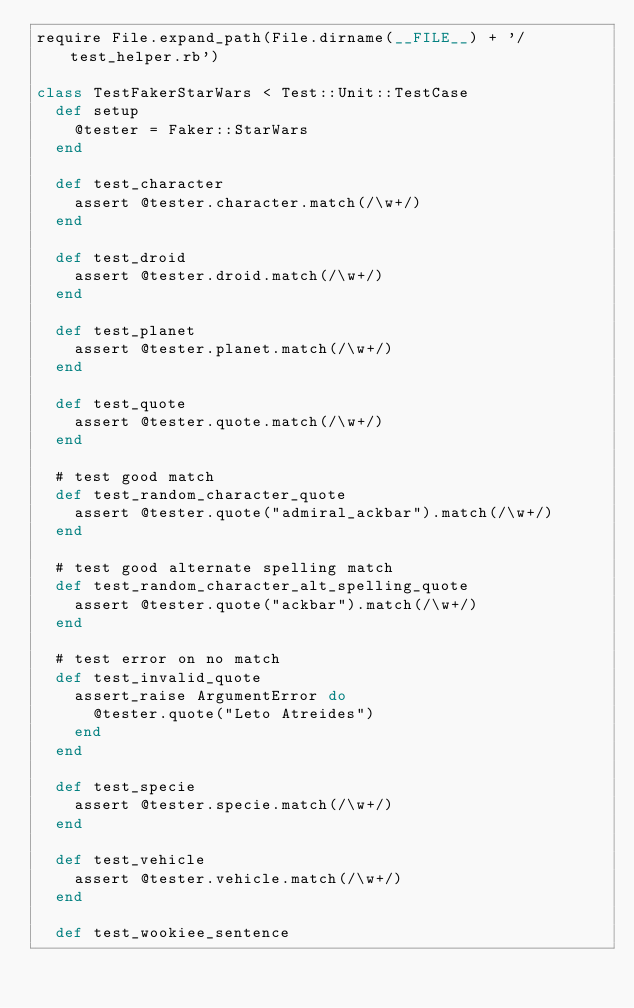Convert code to text. <code><loc_0><loc_0><loc_500><loc_500><_Ruby_>require File.expand_path(File.dirname(__FILE__) + '/test_helper.rb')

class TestFakerStarWars < Test::Unit::TestCase
  def setup
    @tester = Faker::StarWars
  end

  def test_character
    assert @tester.character.match(/\w+/)
  end

  def test_droid
    assert @tester.droid.match(/\w+/)
  end

  def test_planet
    assert @tester.planet.match(/\w+/)
  end

  def test_quote
    assert @tester.quote.match(/\w+/)
  end

  # test good match
  def test_random_character_quote
    assert @tester.quote("admiral_ackbar").match(/\w+/)
  end

  # test good alternate spelling match
  def test_random_character_alt_spelling_quote
    assert @tester.quote("ackbar").match(/\w+/)
  end

  # test error on no match
  def test_invalid_quote
    assert_raise ArgumentError do
      @tester.quote("Leto Atreides")
    end
  end

  def test_specie
    assert @tester.specie.match(/\w+/)
  end

  def test_vehicle
    assert @tester.vehicle.match(/\w+/)
  end

  def test_wookiee_sentence</code> 